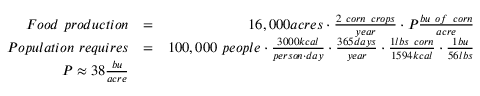Convert formula to latex. <formula><loc_0><loc_0><loc_500><loc_500>\begin{array} { r l r } { F o o d p r o d u c t i o n } & { = } & { 1 6 , 0 0 0 a c r e s \cdot \frac { 2 c o r n c r o p s } { y e a r } \cdot P \frac { b u o f c o r n } { a c r e } } \\ { P o p u l a t i o n r e q u i r e s } & { = } & { 1 0 0 , 0 0 0 p e o p l e \cdot \frac { 3 0 0 0 k c a l } { p e r s o n \cdot d a y } \cdot \frac { 3 6 5 d a y s } { y e a r } \cdot \frac { 1 l b s c o r n } { 1 5 9 4 k c a l } \cdot \frac { 1 b u } { 5 6 l b s } } \\ { P \approx 3 8 \frac { b u } { a c r e } } & \end{array}</formula> 